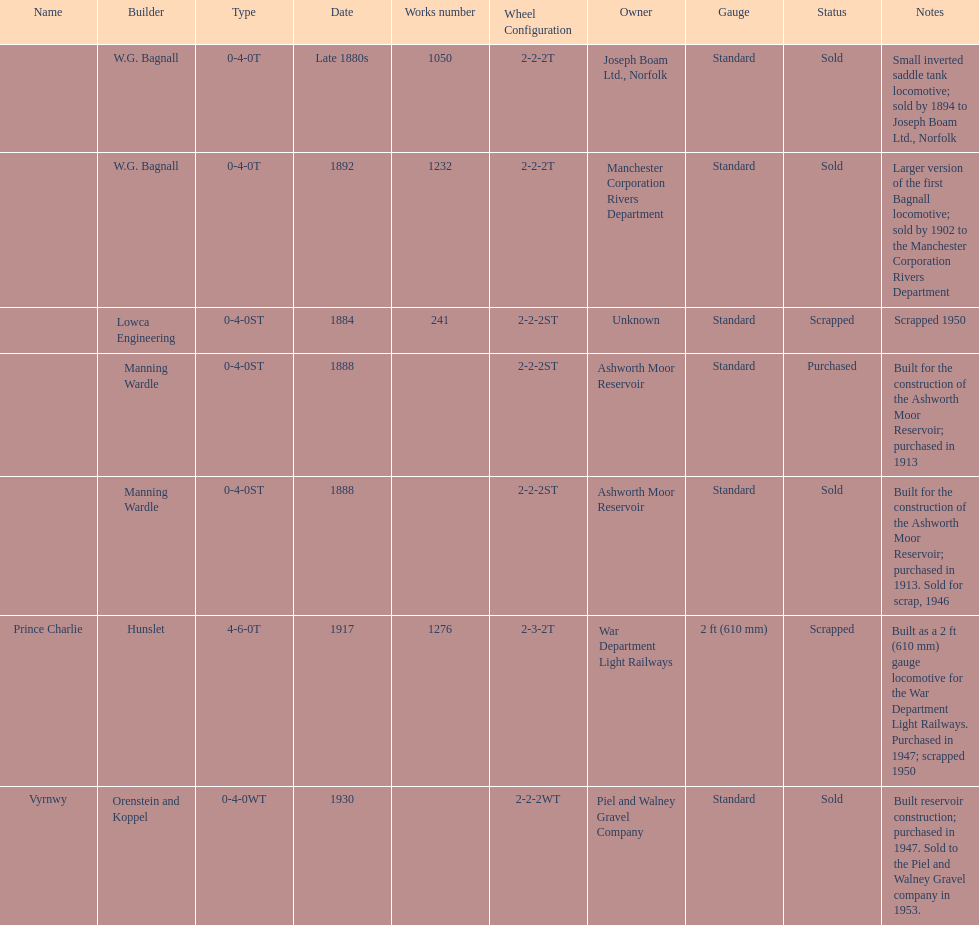How many locomotives were scrapped? 3. 